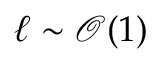Convert formula to latex. <formula><loc_0><loc_0><loc_500><loc_500>\ell \sim \mathcal { O } ( 1 )</formula> 